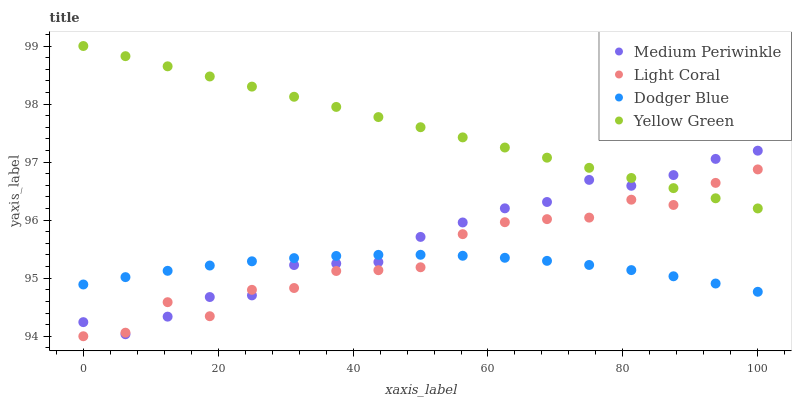Does Dodger Blue have the minimum area under the curve?
Answer yes or no. Yes. Does Yellow Green have the maximum area under the curve?
Answer yes or no. Yes. Does Medium Periwinkle have the minimum area under the curve?
Answer yes or no. No. Does Medium Periwinkle have the maximum area under the curve?
Answer yes or no. No. Is Yellow Green the smoothest?
Answer yes or no. Yes. Is Light Coral the roughest?
Answer yes or no. Yes. Is Dodger Blue the smoothest?
Answer yes or no. No. Is Dodger Blue the roughest?
Answer yes or no. No. Does Light Coral have the lowest value?
Answer yes or no. Yes. Does Dodger Blue have the lowest value?
Answer yes or no. No. Does Yellow Green have the highest value?
Answer yes or no. Yes. Does Medium Periwinkle have the highest value?
Answer yes or no. No. Is Dodger Blue less than Yellow Green?
Answer yes or no. Yes. Is Yellow Green greater than Dodger Blue?
Answer yes or no. Yes. Does Dodger Blue intersect Medium Periwinkle?
Answer yes or no. Yes. Is Dodger Blue less than Medium Periwinkle?
Answer yes or no. No. Is Dodger Blue greater than Medium Periwinkle?
Answer yes or no. No. Does Dodger Blue intersect Yellow Green?
Answer yes or no. No. 